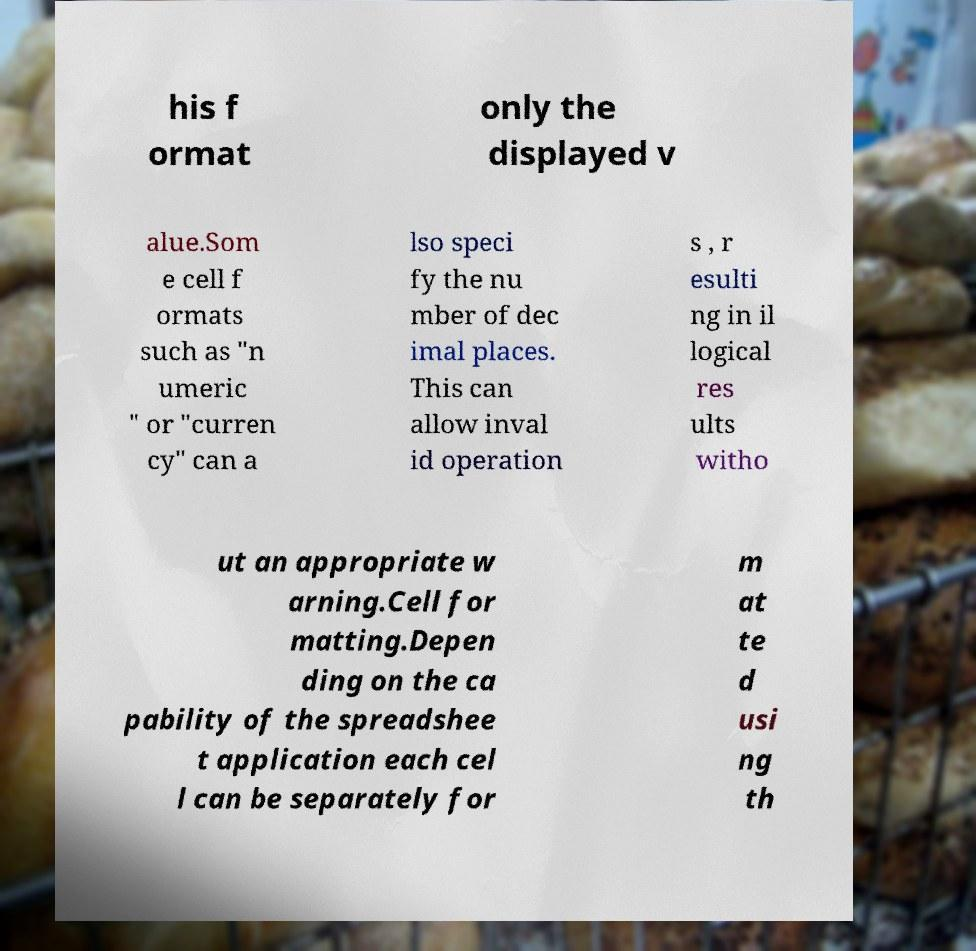For documentation purposes, I need the text within this image transcribed. Could you provide that? his f ormat only the displayed v alue.Som e cell f ormats such as "n umeric " or "curren cy" can a lso speci fy the nu mber of dec imal places. This can allow inval id operation s , r esulti ng in il logical res ults witho ut an appropriate w arning.Cell for matting.Depen ding on the ca pability of the spreadshee t application each cel l can be separately for m at te d usi ng th 